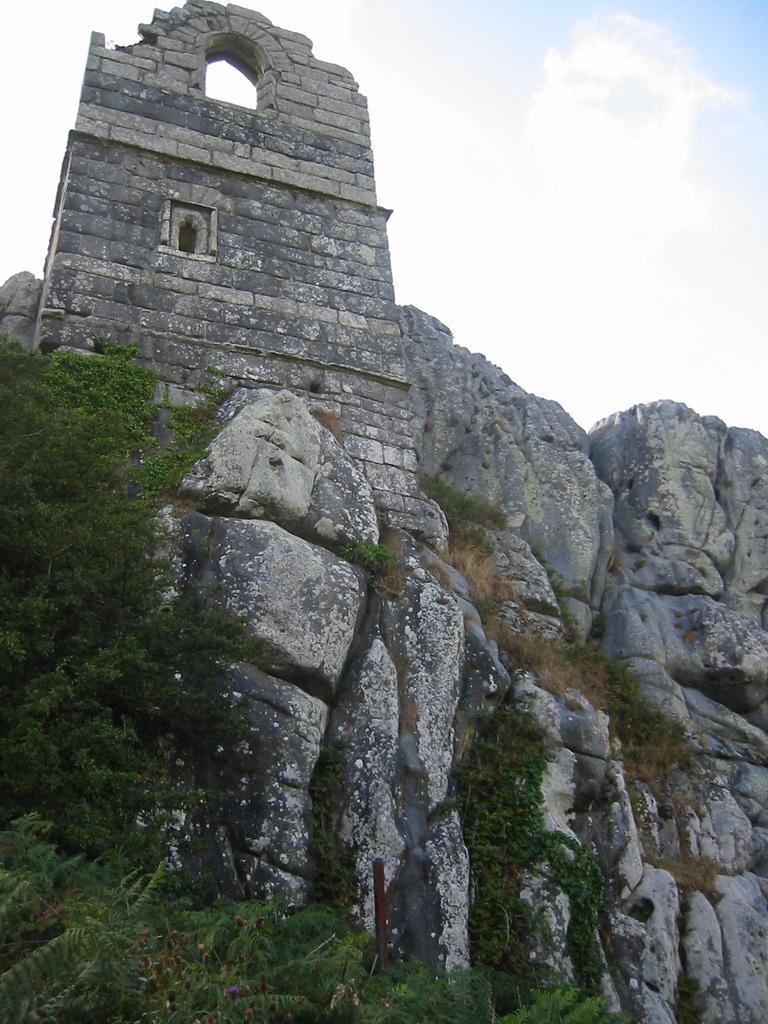How would you summarize this image in a sentence or two? This image is taken outdoors. At the top of the image there is a sky with clouds. On the left side of the image there are a few trees and there is a wall on the rocks. In the middle of the image there are many rocks. 